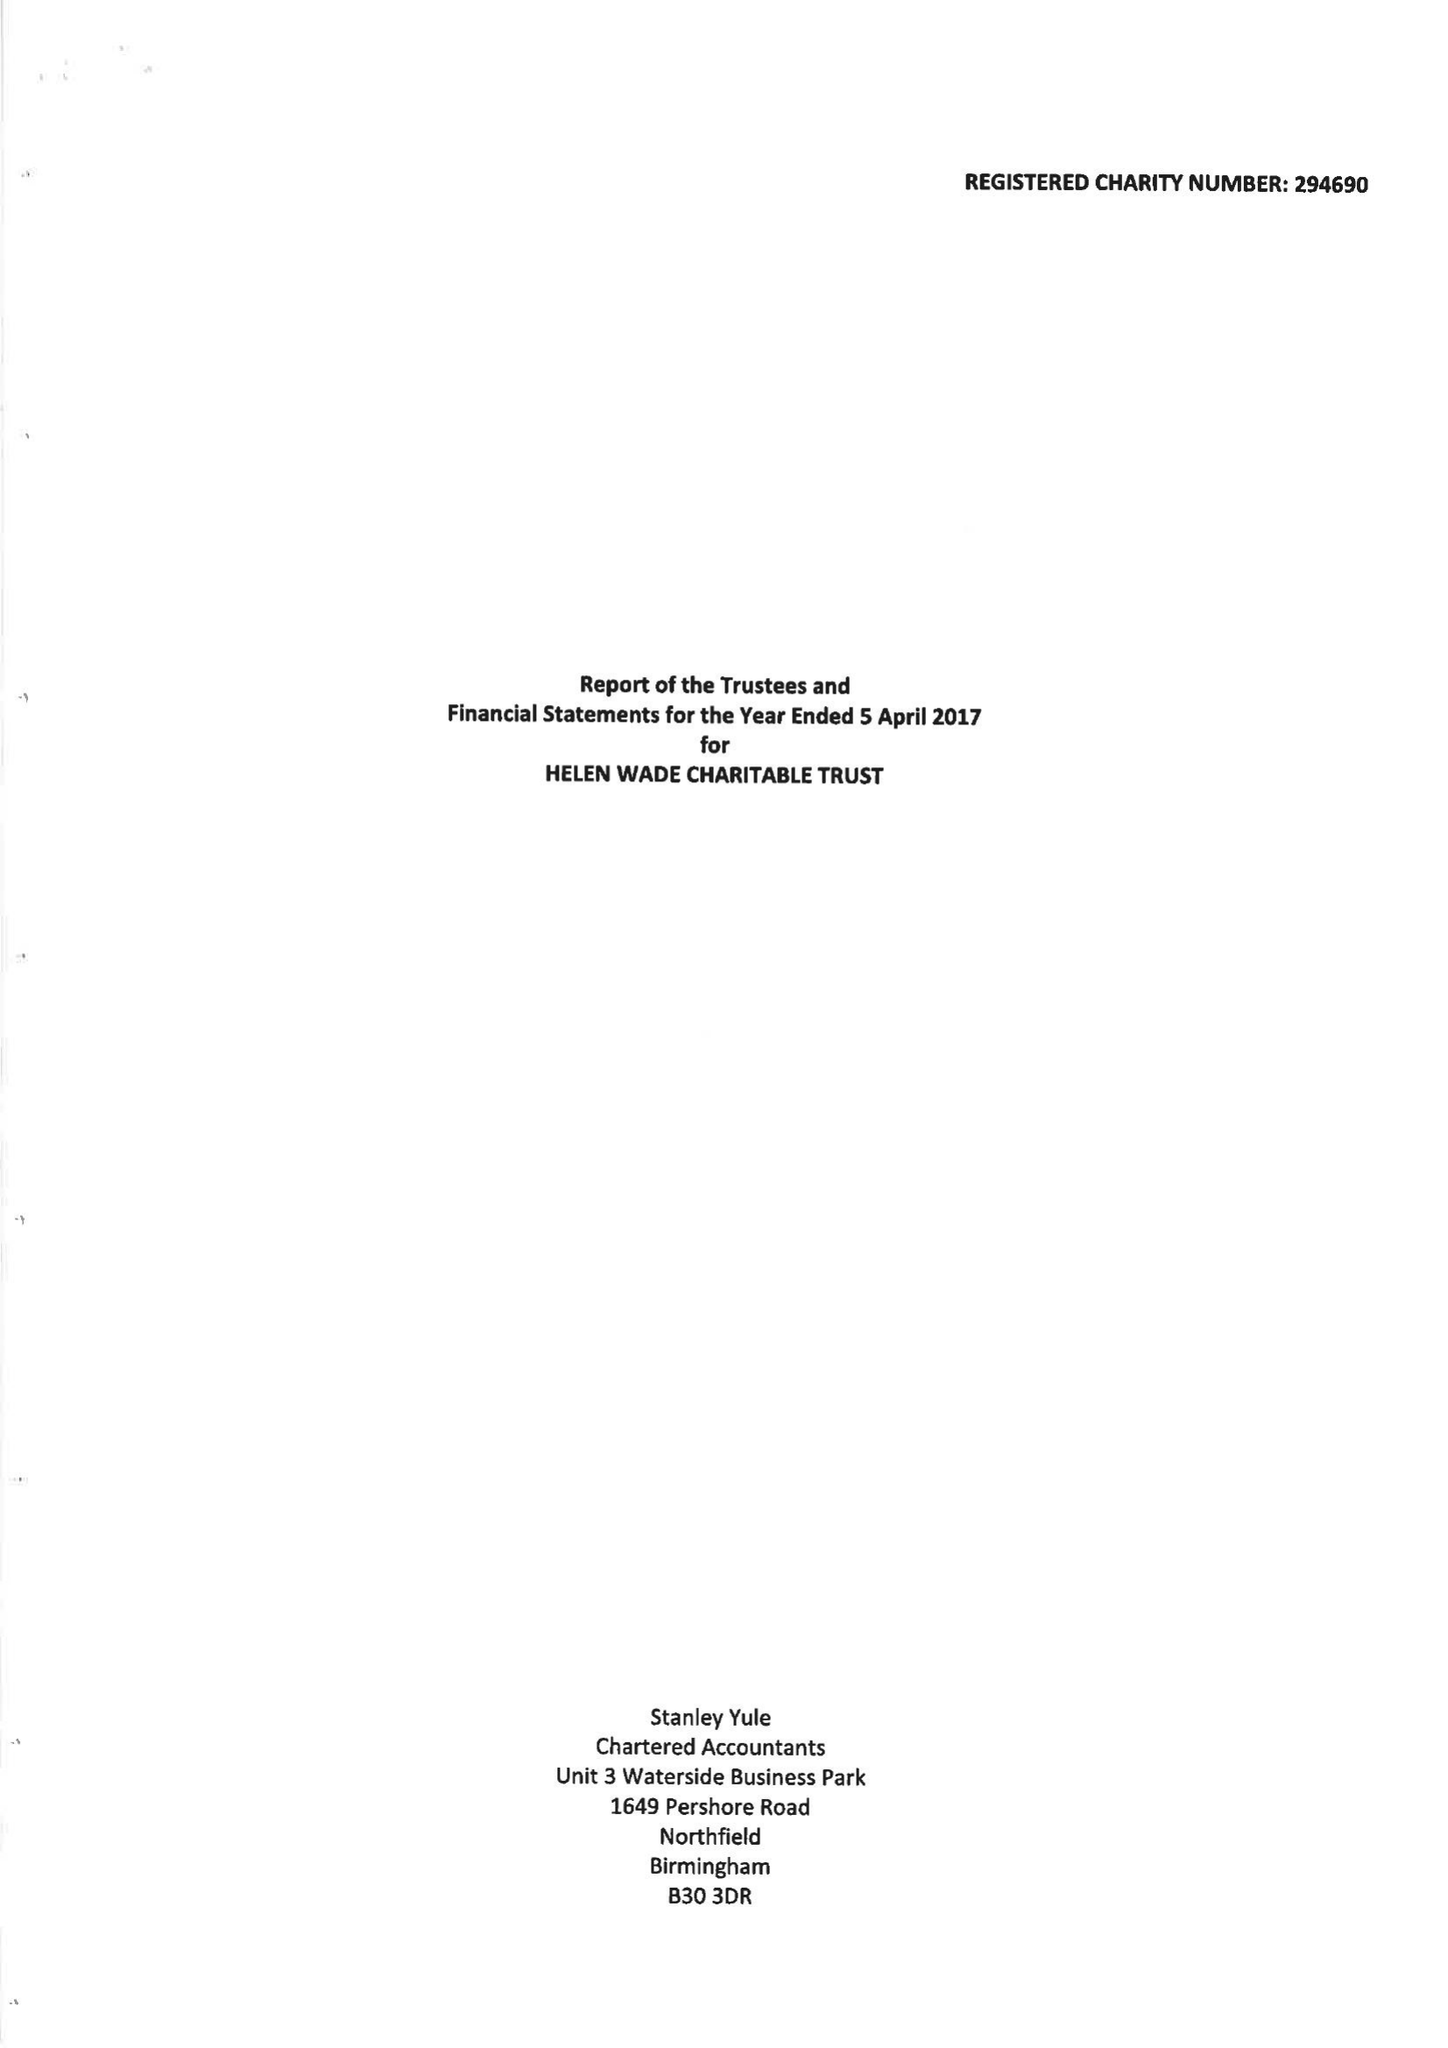What is the value for the address__post_town?
Answer the question using a single word or phrase. TUNBRIDGE WELLS 